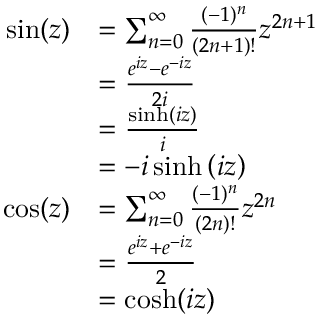<formula> <loc_0><loc_0><loc_500><loc_500>{ \begin{array} { r l } { \sin ( z ) } & { = \sum _ { n = 0 } ^ { \infty } { \frac { ( - 1 ) ^ { n } } { ( 2 n + 1 ) ! } } z ^ { 2 n + 1 } } \\ & { = { \frac { e ^ { i z } - e ^ { - i z } } { 2 i } } } \\ & { = { \frac { \sinh \left ( i z \right ) } { i } } } \\ & { = - i \sinh \left ( i z \right ) } \\ { \cos ( z ) } & { = \sum _ { n = 0 } ^ { \infty } { \frac { ( - 1 ) ^ { n } } { ( 2 n ) ! } } z ^ { 2 n } } \\ & { = { \frac { e ^ { i z } + e ^ { - i z } } { 2 } } } \\ & { = \cosh ( i z ) } \end{array} }</formula> 